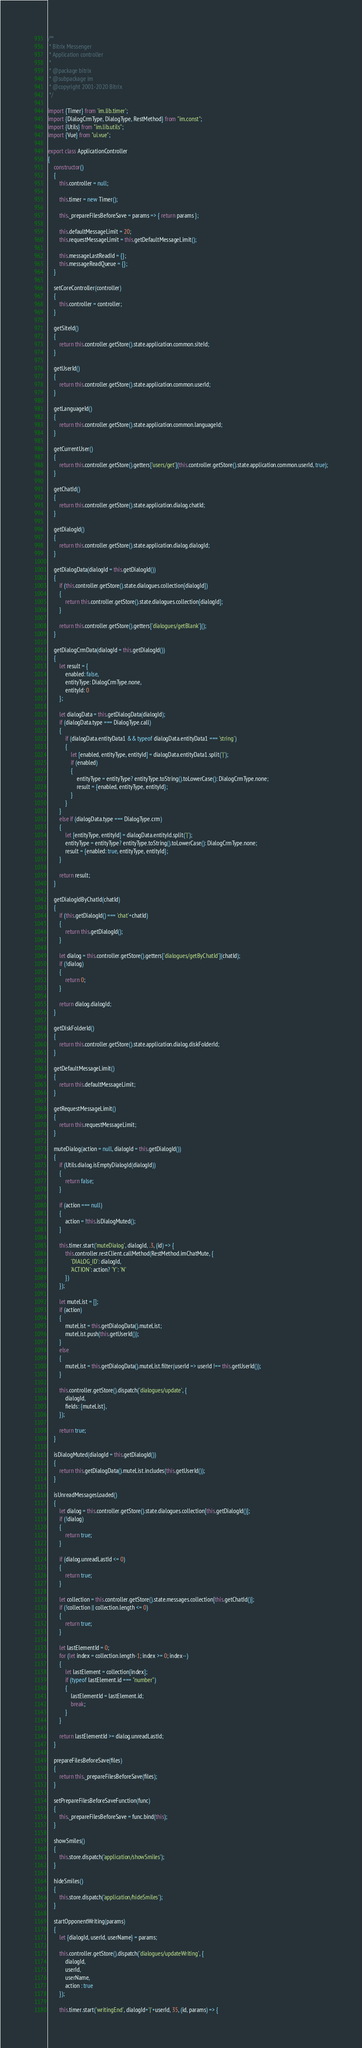<code> <loc_0><loc_0><loc_500><loc_500><_JavaScript_>/**
 * Bitrix Messenger
 * Application controller
 *
 * @package bitrix
 * @subpackage im
 * @copyright 2001-2020 Bitrix
 */

import {Timer} from 'im.lib.timer';
import {DialogCrmType, DialogType, RestMethod} from "im.const";
import {Utils} from "im.lib.utils";
import {Vue} from "ui.vue";

export class ApplicationController
{
	constructor()
	{
		this.controller = null;

		this.timer = new Timer();

		this._prepareFilesBeforeSave = params => { return params };

		this.defaultMessageLimit = 20;
		this.requestMessageLimit = this.getDefaultMessageLimit();

		this.messageLastReadId = {};
		this.messageReadQueue = {};
	}

	setCoreController(controller)
	{
		this.controller = controller;
	}

	getSiteId()
	{
		return this.controller.getStore().state.application.common.siteId;
	}

	getUserId()
	{
		return this.controller.getStore().state.application.common.userId;
	}

	getLanguageId()
	{
		return this.controller.getStore().state.application.common.languageId;
	}

	getCurrentUser()
	{
		return this.controller.getStore().getters['users/get'](this.controller.getStore().state.application.common.userId, true);
	}

	getChatId()
	{
		return this.controller.getStore().state.application.dialog.chatId;
	}

	getDialogId()
	{
		return this.controller.getStore().state.application.dialog.dialogId;
	}

	getDialogData(dialogId = this.getDialogId())
	{
		if (this.controller.getStore().state.dialogues.collection[dialogId])
		{
			return this.controller.getStore().state.dialogues.collection[dialogId];
		}

		return this.controller.getStore().getters['dialogues/getBlank']();
	}

	getDialogCrmData(dialogId = this.getDialogId())
	{
		let result = {
			enabled: false,
			entityType: DialogCrmType.none,
			entityId: 0
		};

		let dialogData = this.getDialogData(dialogId);
		if (dialogData.type === DialogType.call)
		{
			if (dialogData.entityData1 && typeof dialogData.entityData1 === 'string')
			{
				let [enabled, entityType, entityId] = dialogData.entityData1.split('|');
				if (enabled)
				{
					entityType = entityType? entityType.toString().toLowerCase(): DialogCrmType.none;
					result = {enabled, entityType, entityId};
				}
			}
		}
		else if (dialogData.type === DialogType.crm)
		{
			let [entityType, entityId] = dialogData.entityId.split('|');
			entityType = entityType? entityType.toString().toLowerCase(): DialogCrmType.none;
			result = {enabled: true, entityType, entityId};
		}

		return result;
	}

	getDialogIdByChatId(chatId)
	{
		if (this.getDialogId() === 'chat'+chatId)
		{
			return this.getDialogId();
		}

		let dialog = this.controller.getStore().getters['dialogues/getByChatId'](chatId);
		if (!dialog)
		{
			return 0;
		}

		return dialog.dialogId;
	}

	getDiskFolderId()
	{
		return this.controller.getStore().state.application.dialog.diskFolderId;
	}

	getDefaultMessageLimit()
	{
		return this.defaultMessageLimit;
	}

	getRequestMessageLimit()
	{
		return this.requestMessageLimit;
	}

	muteDialog(action = null, dialogId = this.getDialogId())
	{
		if (Utils.dialog.isEmptyDialogId(dialogId))
		{
			return false;
		}

		if (action === null)
		{
			action = !this.isDialogMuted();
		}

		this.timer.start('muteDialog', dialogId, .3, (id) => {
			this.controller.restClient.callMethod(RestMethod.imChatMute, {
				'DIALOG_ID': dialogId,
				'ACTION': action? 'Y': 'N'
			})
		});

		let muteList = [];
		if (action)
		{
			muteList = this.getDialogData().muteList;
			muteList.push(this.getUserId());
		}
		else
		{
			muteList = this.getDialogData().muteList.filter(userId => userId !== this.getUserId());
		}

		this.controller.getStore().dispatch('dialogues/update', {
			dialogId,
			fields: {muteList},
		});

		return true;
	}

	isDialogMuted(dialogId = this.getDialogId())
	{
		return this.getDialogData().muteList.includes(this.getUserId());
	}

	isUnreadMessagesLoaded()
	{
		let dialog = this.controller.getStore().state.dialogues.collection[this.getDialogId()];
		if (!dialog)
		{
			return true;
		}

		if (dialog.unreadLastId <= 0)
		{
			return true;
		}

		let collection = this.controller.getStore().state.messages.collection[this.getChatId()];
		if (!collection || collection.length <= 0)
		{
			return true;
		}

		let lastElementId = 0;
		for (let index = collection.length-1; index >= 0; index--)
		{
			let lastElement = collection[index];
			if (typeof lastElement.id === "number")
			{
				lastElementId = lastElement.id;
				break;
			}
		}

		return lastElementId >= dialog.unreadLastId;
	}

	prepareFilesBeforeSave(files)
	{
		return this._prepareFilesBeforeSave(files);
	}

	setPrepareFilesBeforeSaveFunction(func)
	{
		this._prepareFilesBeforeSave = func.bind(this);
	}

	showSmiles()
	{
		this.store.dispatch('application/showSmiles');
	}

	hideSmiles()
	{
		this.store.dispatch('application/hideSmiles');
	}

	startOpponentWriting(params)
	{
		let {dialogId, userId, userName} = params;

		this.controller.getStore().dispatch('dialogues/updateWriting', {
			dialogId,
			userId,
			userName,
			action : true
		});

		this.timer.start('writingEnd', dialogId+'|'+userId, 35, (id, params) => {</code> 